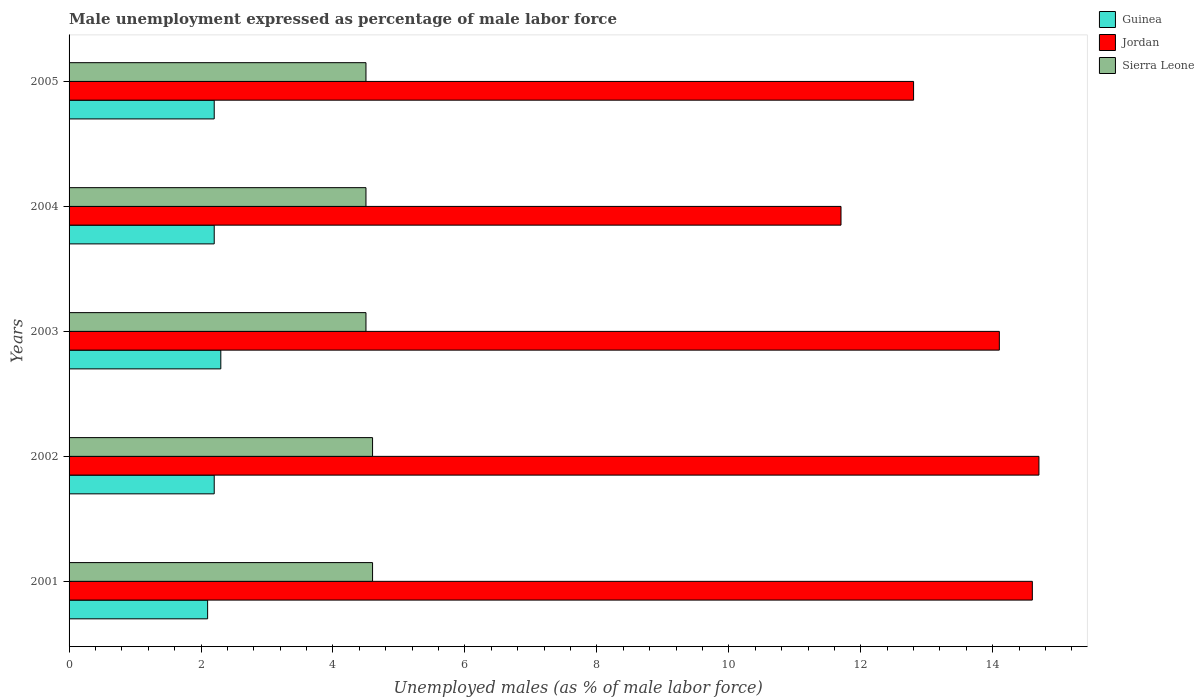How many different coloured bars are there?
Ensure brevity in your answer.  3. Are the number of bars per tick equal to the number of legend labels?
Offer a very short reply. Yes. Are the number of bars on each tick of the Y-axis equal?
Provide a succinct answer. Yes. How many bars are there on the 2nd tick from the top?
Offer a very short reply. 3. In how many cases, is the number of bars for a given year not equal to the number of legend labels?
Offer a very short reply. 0. Across all years, what is the maximum unemployment in males in in Guinea?
Your answer should be very brief. 2.3. Across all years, what is the minimum unemployment in males in in Jordan?
Ensure brevity in your answer.  11.7. In which year was the unemployment in males in in Sierra Leone maximum?
Your answer should be compact. 2001. What is the total unemployment in males in in Guinea in the graph?
Your answer should be very brief. 11. What is the difference between the unemployment in males in in Guinea in 2001 and that in 2003?
Offer a terse response. -0.2. What is the difference between the unemployment in males in in Jordan in 2005 and the unemployment in males in in Guinea in 2002?
Your answer should be compact. 10.6. What is the average unemployment in males in in Sierra Leone per year?
Ensure brevity in your answer.  4.54. In the year 2001, what is the difference between the unemployment in males in in Sierra Leone and unemployment in males in in Guinea?
Offer a terse response. 2.5. What is the ratio of the unemployment in males in in Jordan in 2003 to that in 2005?
Your answer should be very brief. 1.1. What is the difference between the highest and the second highest unemployment in males in in Guinea?
Offer a very short reply. 0.1. Is the sum of the unemployment in males in in Jordan in 2001 and 2003 greater than the maximum unemployment in males in in Sierra Leone across all years?
Give a very brief answer. Yes. What does the 3rd bar from the top in 2002 represents?
Your response must be concise. Guinea. What does the 3rd bar from the bottom in 2002 represents?
Offer a terse response. Sierra Leone. Is it the case that in every year, the sum of the unemployment in males in in Sierra Leone and unemployment in males in in Jordan is greater than the unemployment in males in in Guinea?
Provide a succinct answer. Yes. How many bars are there?
Offer a very short reply. 15. Does the graph contain any zero values?
Ensure brevity in your answer.  No. Does the graph contain grids?
Your answer should be very brief. No. Where does the legend appear in the graph?
Make the answer very short. Top right. How are the legend labels stacked?
Offer a terse response. Vertical. What is the title of the graph?
Offer a very short reply. Male unemployment expressed as percentage of male labor force. Does "Netherlands" appear as one of the legend labels in the graph?
Make the answer very short. No. What is the label or title of the X-axis?
Give a very brief answer. Unemployed males (as % of male labor force). What is the label or title of the Y-axis?
Offer a very short reply. Years. What is the Unemployed males (as % of male labor force) of Guinea in 2001?
Your answer should be very brief. 2.1. What is the Unemployed males (as % of male labor force) of Jordan in 2001?
Keep it short and to the point. 14.6. What is the Unemployed males (as % of male labor force) of Sierra Leone in 2001?
Your answer should be very brief. 4.6. What is the Unemployed males (as % of male labor force) of Guinea in 2002?
Your answer should be compact. 2.2. What is the Unemployed males (as % of male labor force) of Jordan in 2002?
Provide a short and direct response. 14.7. What is the Unemployed males (as % of male labor force) in Sierra Leone in 2002?
Offer a very short reply. 4.6. What is the Unemployed males (as % of male labor force) of Guinea in 2003?
Keep it short and to the point. 2.3. What is the Unemployed males (as % of male labor force) of Jordan in 2003?
Your answer should be compact. 14.1. What is the Unemployed males (as % of male labor force) of Guinea in 2004?
Keep it short and to the point. 2.2. What is the Unemployed males (as % of male labor force) of Jordan in 2004?
Provide a succinct answer. 11.7. What is the Unemployed males (as % of male labor force) of Guinea in 2005?
Make the answer very short. 2.2. What is the Unemployed males (as % of male labor force) in Jordan in 2005?
Your answer should be compact. 12.8. What is the Unemployed males (as % of male labor force) of Sierra Leone in 2005?
Offer a terse response. 4.5. Across all years, what is the maximum Unemployed males (as % of male labor force) in Guinea?
Give a very brief answer. 2.3. Across all years, what is the maximum Unemployed males (as % of male labor force) of Jordan?
Your response must be concise. 14.7. Across all years, what is the maximum Unemployed males (as % of male labor force) of Sierra Leone?
Offer a terse response. 4.6. Across all years, what is the minimum Unemployed males (as % of male labor force) in Guinea?
Your answer should be very brief. 2.1. Across all years, what is the minimum Unemployed males (as % of male labor force) of Jordan?
Ensure brevity in your answer.  11.7. Across all years, what is the minimum Unemployed males (as % of male labor force) in Sierra Leone?
Your answer should be very brief. 4.5. What is the total Unemployed males (as % of male labor force) in Guinea in the graph?
Offer a terse response. 11. What is the total Unemployed males (as % of male labor force) in Jordan in the graph?
Provide a succinct answer. 67.9. What is the total Unemployed males (as % of male labor force) of Sierra Leone in the graph?
Make the answer very short. 22.7. What is the difference between the Unemployed males (as % of male labor force) of Sierra Leone in 2001 and that in 2002?
Give a very brief answer. 0. What is the difference between the Unemployed males (as % of male labor force) of Jordan in 2001 and that in 2003?
Your answer should be very brief. 0.5. What is the difference between the Unemployed males (as % of male labor force) in Guinea in 2001 and that in 2004?
Offer a very short reply. -0.1. What is the difference between the Unemployed males (as % of male labor force) of Jordan in 2002 and that in 2004?
Your response must be concise. 3. What is the difference between the Unemployed males (as % of male labor force) of Sierra Leone in 2002 and that in 2004?
Your answer should be compact. 0.1. What is the difference between the Unemployed males (as % of male labor force) of Guinea in 2002 and that in 2005?
Your answer should be very brief. 0. What is the difference between the Unemployed males (as % of male labor force) of Jordan in 2003 and that in 2004?
Ensure brevity in your answer.  2.4. What is the difference between the Unemployed males (as % of male labor force) in Sierra Leone in 2003 and that in 2004?
Your answer should be compact. 0. What is the difference between the Unemployed males (as % of male labor force) in Guinea in 2003 and that in 2005?
Offer a terse response. 0.1. What is the difference between the Unemployed males (as % of male labor force) in Jordan in 2003 and that in 2005?
Offer a terse response. 1.3. What is the difference between the Unemployed males (as % of male labor force) in Sierra Leone in 2003 and that in 2005?
Your answer should be very brief. 0. What is the difference between the Unemployed males (as % of male labor force) in Sierra Leone in 2004 and that in 2005?
Offer a very short reply. 0. What is the difference between the Unemployed males (as % of male labor force) of Guinea in 2001 and the Unemployed males (as % of male labor force) of Jordan in 2002?
Provide a succinct answer. -12.6. What is the difference between the Unemployed males (as % of male labor force) of Jordan in 2001 and the Unemployed males (as % of male labor force) of Sierra Leone in 2002?
Make the answer very short. 10. What is the difference between the Unemployed males (as % of male labor force) in Guinea in 2001 and the Unemployed males (as % of male labor force) in Jordan in 2004?
Your answer should be compact. -9.6. What is the difference between the Unemployed males (as % of male labor force) of Jordan in 2001 and the Unemployed males (as % of male labor force) of Sierra Leone in 2004?
Keep it short and to the point. 10.1. What is the difference between the Unemployed males (as % of male labor force) of Guinea in 2001 and the Unemployed males (as % of male labor force) of Jordan in 2005?
Offer a terse response. -10.7. What is the difference between the Unemployed males (as % of male labor force) of Guinea in 2001 and the Unemployed males (as % of male labor force) of Sierra Leone in 2005?
Give a very brief answer. -2.4. What is the difference between the Unemployed males (as % of male labor force) in Guinea in 2002 and the Unemployed males (as % of male labor force) in Jordan in 2003?
Your answer should be compact. -11.9. What is the difference between the Unemployed males (as % of male labor force) in Guinea in 2002 and the Unemployed males (as % of male labor force) in Sierra Leone in 2003?
Give a very brief answer. -2.3. What is the difference between the Unemployed males (as % of male labor force) in Guinea in 2002 and the Unemployed males (as % of male labor force) in Sierra Leone in 2004?
Your answer should be very brief. -2.3. What is the difference between the Unemployed males (as % of male labor force) in Jordan in 2002 and the Unemployed males (as % of male labor force) in Sierra Leone in 2004?
Make the answer very short. 10.2. What is the difference between the Unemployed males (as % of male labor force) in Guinea in 2003 and the Unemployed males (as % of male labor force) in Jordan in 2004?
Ensure brevity in your answer.  -9.4. What is the difference between the Unemployed males (as % of male labor force) in Guinea in 2003 and the Unemployed males (as % of male labor force) in Jordan in 2005?
Provide a succinct answer. -10.5. What is the difference between the Unemployed males (as % of male labor force) in Guinea in 2003 and the Unemployed males (as % of male labor force) in Sierra Leone in 2005?
Provide a short and direct response. -2.2. What is the difference between the Unemployed males (as % of male labor force) in Jordan in 2004 and the Unemployed males (as % of male labor force) in Sierra Leone in 2005?
Make the answer very short. 7.2. What is the average Unemployed males (as % of male labor force) in Jordan per year?
Provide a short and direct response. 13.58. What is the average Unemployed males (as % of male labor force) in Sierra Leone per year?
Provide a short and direct response. 4.54. In the year 2001, what is the difference between the Unemployed males (as % of male labor force) in Jordan and Unemployed males (as % of male labor force) in Sierra Leone?
Make the answer very short. 10. In the year 2003, what is the difference between the Unemployed males (as % of male labor force) in Guinea and Unemployed males (as % of male labor force) in Jordan?
Your answer should be very brief. -11.8. In the year 2003, what is the difference between the Unemployed males (as % of male labor force) in Guinea and Unemployed males (as % of male labor force) in Sierra Leone?
Provide a short and direct response. -2.2. In the year 2003, what is the difference between the Unemployed males (as % of male labor force) in Jordan and Unemployed males (as % of male labor force) in Sierra Leone?
Provide a short and direct response. 9.6. In the year 2005, what is the difference between the Unemployed males (as % of male labor force) in Guinea and Unemployed males (as % of male labor force) in Jordan?
Make the answer very short. -10.6. What is the ratio of the Unemployed males (as % of male labor force) in Guinea in 2001 to that in 2002?
Provide a succinct answer. 0.95. What is the ratio of the Unemployed males (as % of male labor force) of Jordan in 2001 to that in 2002?
Offer a terse response. 0.99. What is the ratio of the Unemployed males (as % of male labor force) in Guinea in 2001 to that in 2003?
Your response must be concise. 0.91. What is the ratio of the Unemployed males (as % of male labor force) in Jordan in 2001 to that in 2003?
Offer a very short reply. 1.04. What is the ratio of the Unemployed males (as % of male labor force) of Sierra Leone in 2001 to that in 2003?
Your response must be concise. 1.02. What is the ratio of the Unemployed males (as % of male labor force) of Guinea in 2001 to that in 2004?
Make the answer very short. 0.95. What is the ratio of the Unemployed males (as % of male labor force) of Jordan in 2001 to that in 2004?
Your answer should be very brief. 1.25. What is the ratio of the Unemployed males (as % of male labor force) in Sierra Leone in 2001 to that in 2004?
Ensure brevity in your answer.  1.02. What is the ratio of the Unemployed males (as % of male labor force) of Guinea in 2001 to that in 2005?
Provide a short and direct response. 0.95. What is the ratio of the Unemployed males (as % of male labor force) of Jordan in 2001 to that in 2005?
Make the answer very short. 1.14. What is the ratio of the Unemployed males (as % of male labor force) of Sierra Leone in 2001 to that in 2005?
Give a very brief answer. 1.02. What is the ratio of the Unemployed males (as % of male labor force) in Guinea in 2002 to that in 2003?
Your response must be concise. 0.96. What is the ratio of the Unemployed males (as % of male labor force) of Jordan in 2002 to that in 2003?
Your answer should be very brief. 1.04. What is the ratio of the Unemployed males (as % of male labor force) in Sierra Leone in 2002 to that in 2003?
Provide a succinct answer. 1.02. What is the ratio of the Unemployed males (as % of male labor force) of Guinea in 2002 to that in 2004?
Give a very brief answer. 1. What is the ratio of the Unemployed males (as % of male labor force) of Jordan in 2002 to that in 2004?
Keep it short and to the point. 1.26. What is the ratio of the Unemployed males (as % of male labor force) of Sierra Leone in 2002 to that in 2004?
Give a very brief answer. 1.02. What is the ratio of the Unemployed males (as % of male labor force) of Jordan in 2002 to that in 2005?
Provide a succinct answer. 1.15. What is the ratio of the Unemployed males (as % of male labor force) in Sierra Leone in 2002 to that in 2005?
Make the answer very short. 1.02. What is the ratio of the Unemployed males (as % of male labor force) of Guinea in 2003 to that in 2004?
Your answer should be compact. 1.05. What is the ratio of the Unemployed males (as % of male labor force) of Jordan in 2003 to that in 2004?
Make the answer very short. 1.21. What is the ratio of the Unemployed males (as % of male labor force) in Sierra Leone in 2003 to that in 2004?
Offer a very short reply. 1. What is the ratio of the Unemployed males (as % of male labor force) in Guinea in 2003 to that in 2005?
Offer a terse response. 1.05. What is the ratio of the Unemployed males (as % of male labor force) of Jordan in 2003 to that in 2005?
Ensure brevity in your answer.  1.1. What is the ratio of the Unemployed males (as % of male labor force) in Sierra Leone in 2003 to that in 2005?
Offer a terse response. 1. What is the ratio of the Unemployed males (as % of male labor force) in Guinea in 2004 to that in 2005?
Ensure brevity in your answer.  1. What is the ratio of the Unemployed males (as % of male labor force) of Jordan in 2004 to that in 2005?
Ensure brevity in your answer.  0.91. What is the difference between the highest and the second highest Unemployed males (as % of male labor force) of Guinea?
Ensure brevity in your answer.  0.1. What is the difference between the highest and the second highest Unemployed males (as % of male labor force) in Jordan?
Ensure brevity in your answer.  0.1. What is the difference between the highest and the lowest Unemployed males (as % of male labor force) in Jordan?
Your answer should be compact. 3. What is the difference between the highest and the lowest Unemployed males (as % of male labor force) of Sierra Leone?
Your response must be concise. 0.1. 